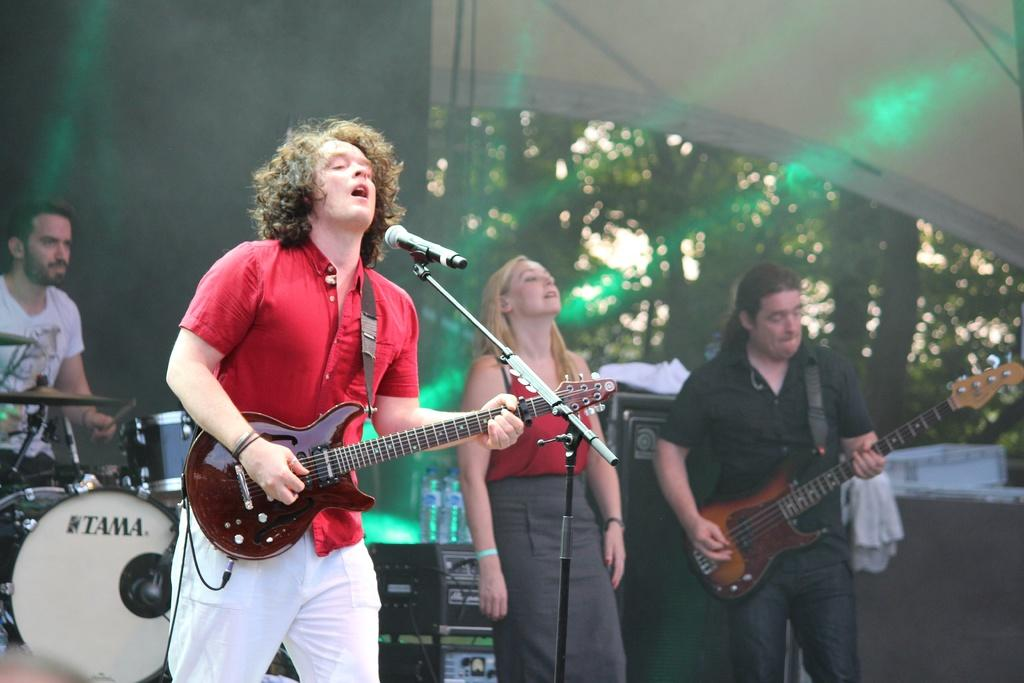How many people are in the image? There is a group of people in the image. What is one person in the group doing? One person is holding a guitar. What equipment is present for amplifying sound? There is a microphone in the image. What musical instrument can be seen in the image? There are musical drums in the image. What type of plant is visible in the image? There is a tree in the image. What type of kettle is being used by the writer in the image? There is no writer or kettle present in the image. 